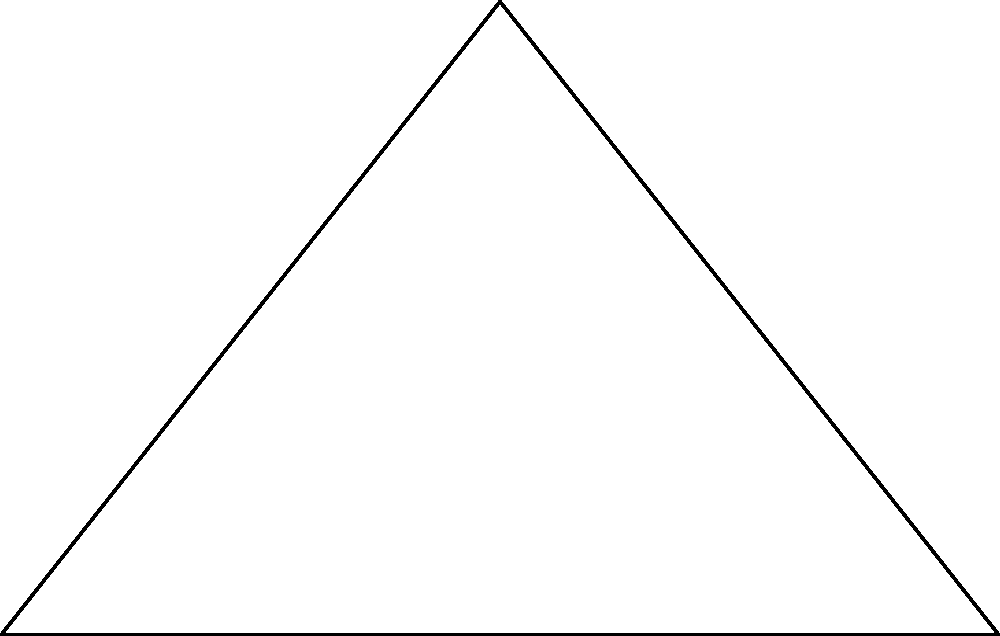As a documentary filmmaker, you're interviewing an Egyptologist about the Great Pyramid of Giza. The expert mentions that the pyramid has a square base with a side length of 230 meters and a height of 146 meters. To better understand the pyramid's structure, you need to determine the slope of its face. What is the slope of the Great Pyramid's face? To find the slope of the pyramid's face, we can follow these steps:

1) The slope of a line is defined as the change in vertical distance (rise) divided by the change in horizontal distance (run).

2) In this case, the rise is the height of the pyramid: 146 meters.

3) The run is half the base length, as we're measuring from the center to one edge:
   $\text{run} = \frac{230 \text{ m}}{2} = 115 \text{ m}$

4) Now we can calculate the slope:
   $\text{slope} = \frac{\text{rise}}{\text{run}} = \frac{146 \text{ m}}{115 \text{ m}}$

5) Simplifying this fraction:
   $\text{slope} = \frac{146}{115} \approx 1.27$

6) This means that for every 1 unit of horizontal distance, the pyramid rises 1.27 units vertically.

7) We can also express this as an angle. The inverse tangent (arctangent) of the slope gives us the angle of inclination:
   $\theta = \tan^{-1}(1.27) \approx 51.8°$

This slope of approximately 1.27, or an angle of about 51.8°, represents the steepness of the Great Pyramid's face.
Answer: $\frac{146}{115} \approx 1.27$ 